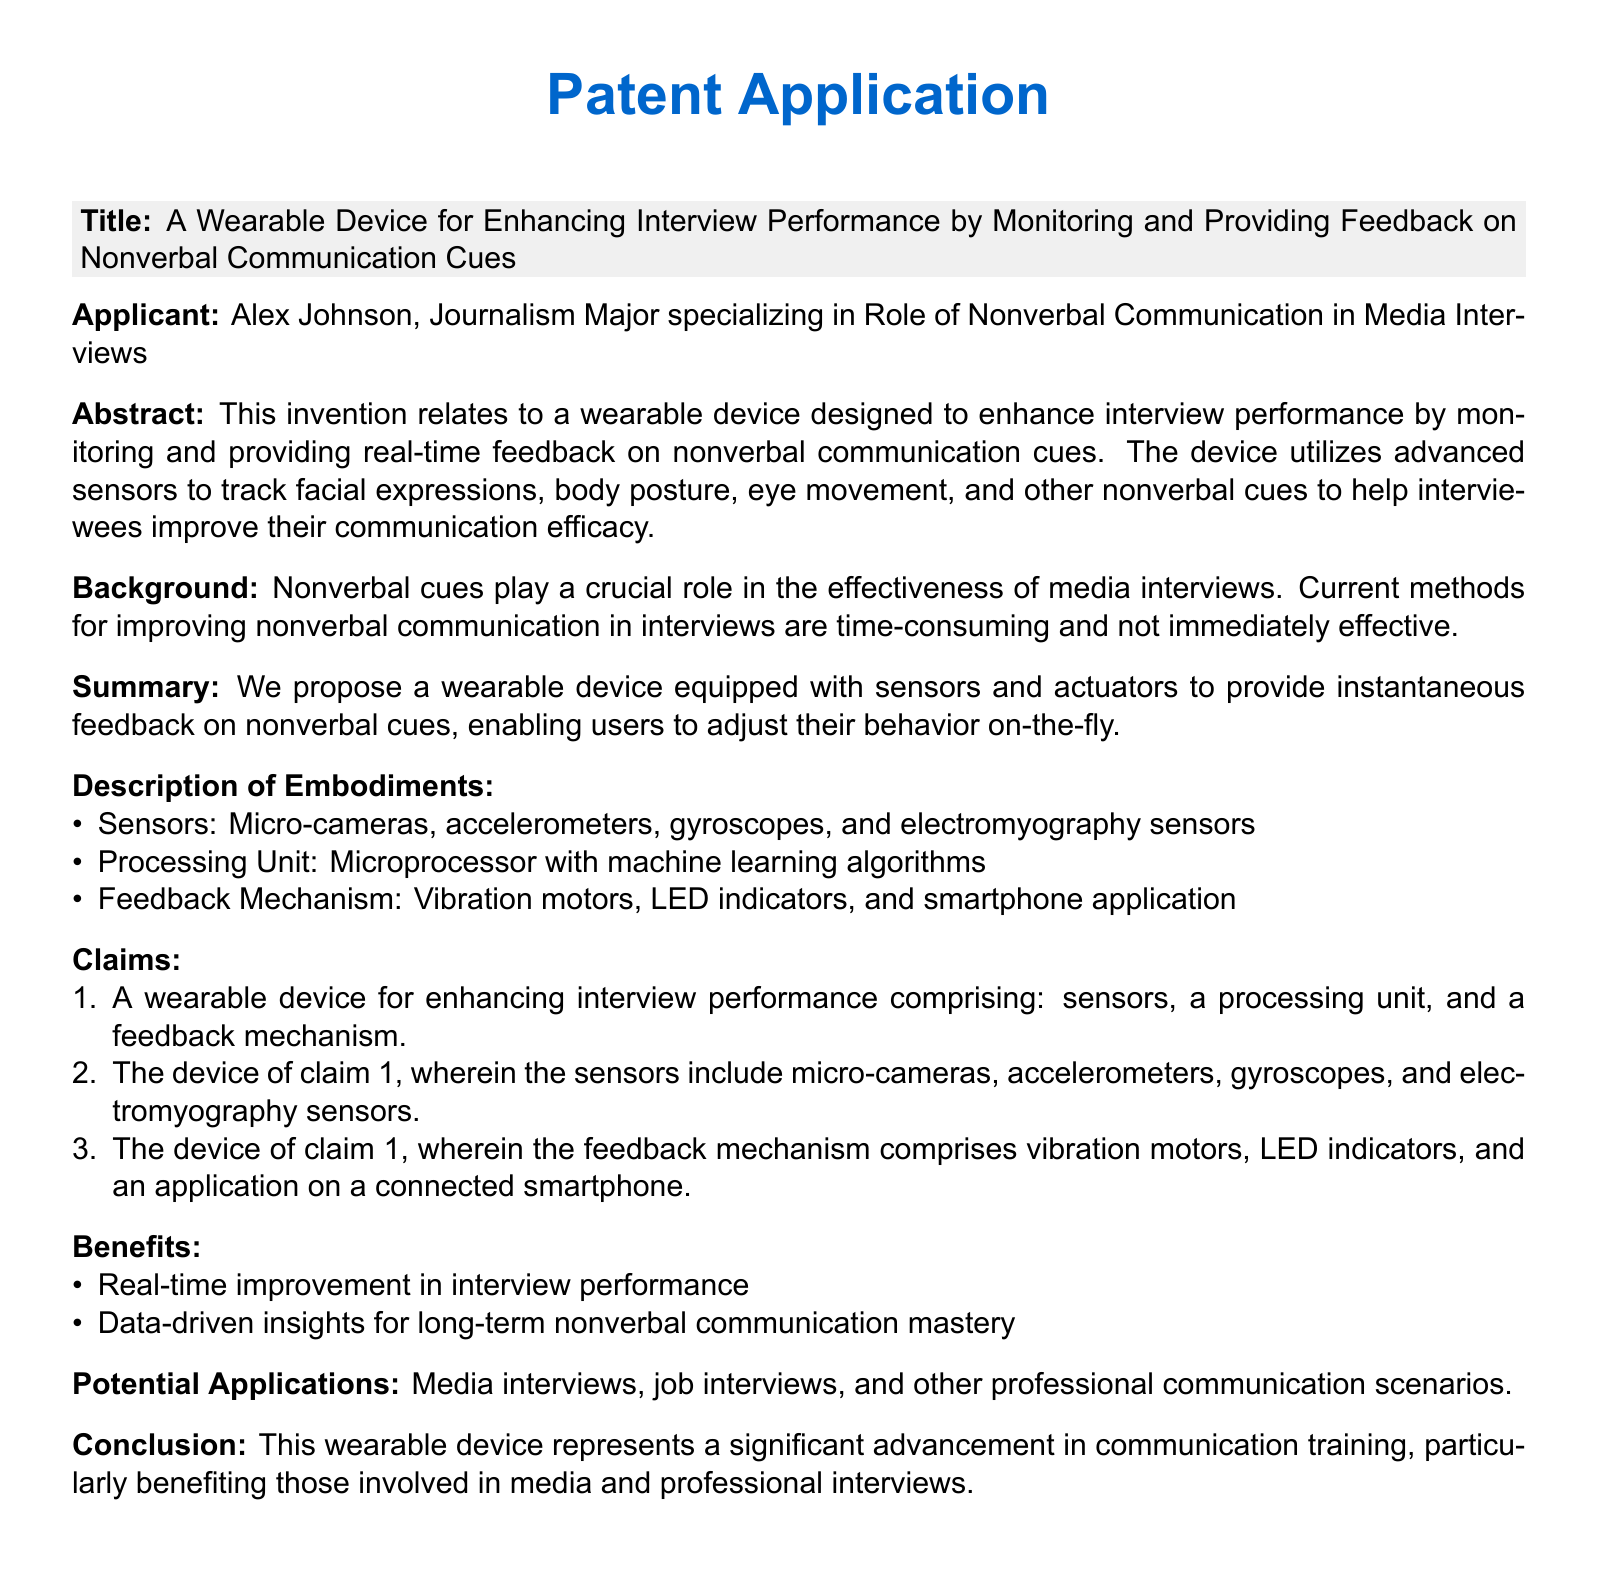What is the title of the patent application? The title of the patent application is found in the section that begins with "Title:", which outlines the main innovation of the document.
Answer: A Wearable Device for Enhancing Interview Performance by Monitoring and Providing Feedback on Nonverbal Communication Cues Who is the applicant? The applicant's name is mentioned directly after the "Applicant:" label, providing information about who is seeking the patent.
Answer: Alex Johnson What are the types of sensors mentioned? The types of sensors are listed in the "Description of Embodiments" section, providing specific details about the technology used in the device.
Answer: Micro-cameras, accelerometers, gyroscopes, and electromyography sensors What is the primary benefit of the wearable device? The benefits of the device are outlined in a bulleted list, indicating the main outcomes it aims to achieve for users.
Answer: Real-time improvement in interview performance What is the feedback mechanism comprised of? The feedback mechanism is described in detail in the claims section, highlighting the components that provide user feedback.
Answer: Vibration motors, LED indicators, and an application on a connected smartphone What type of communication scenarios can benefit from this device? The potential applications are listed in a section of the document, specifying where the device could be utilized effectively.
Answer: Media interviews, job interviews, and other professional communication scenarios What technology is used for processing in the device? The processing technology for the device is mentioned in the "Description of Embodiments," outlining the hardware facilitating data processing.
Answer: Microprocessor with machine learning algorithms How does the device provide feedback? The feedback provision method is described under the feedback mechanism, detailing how users will receive alerts or information.
Answer: Vibration motors, LED indicators, and smartphone application What is the main focus of the applicant's study? The focus of the applicant's study is noted in the title section and the applicant's description, laying out their area of expertise and interest.
Answer: Role of Nonverbal Communication in Media Interviews 